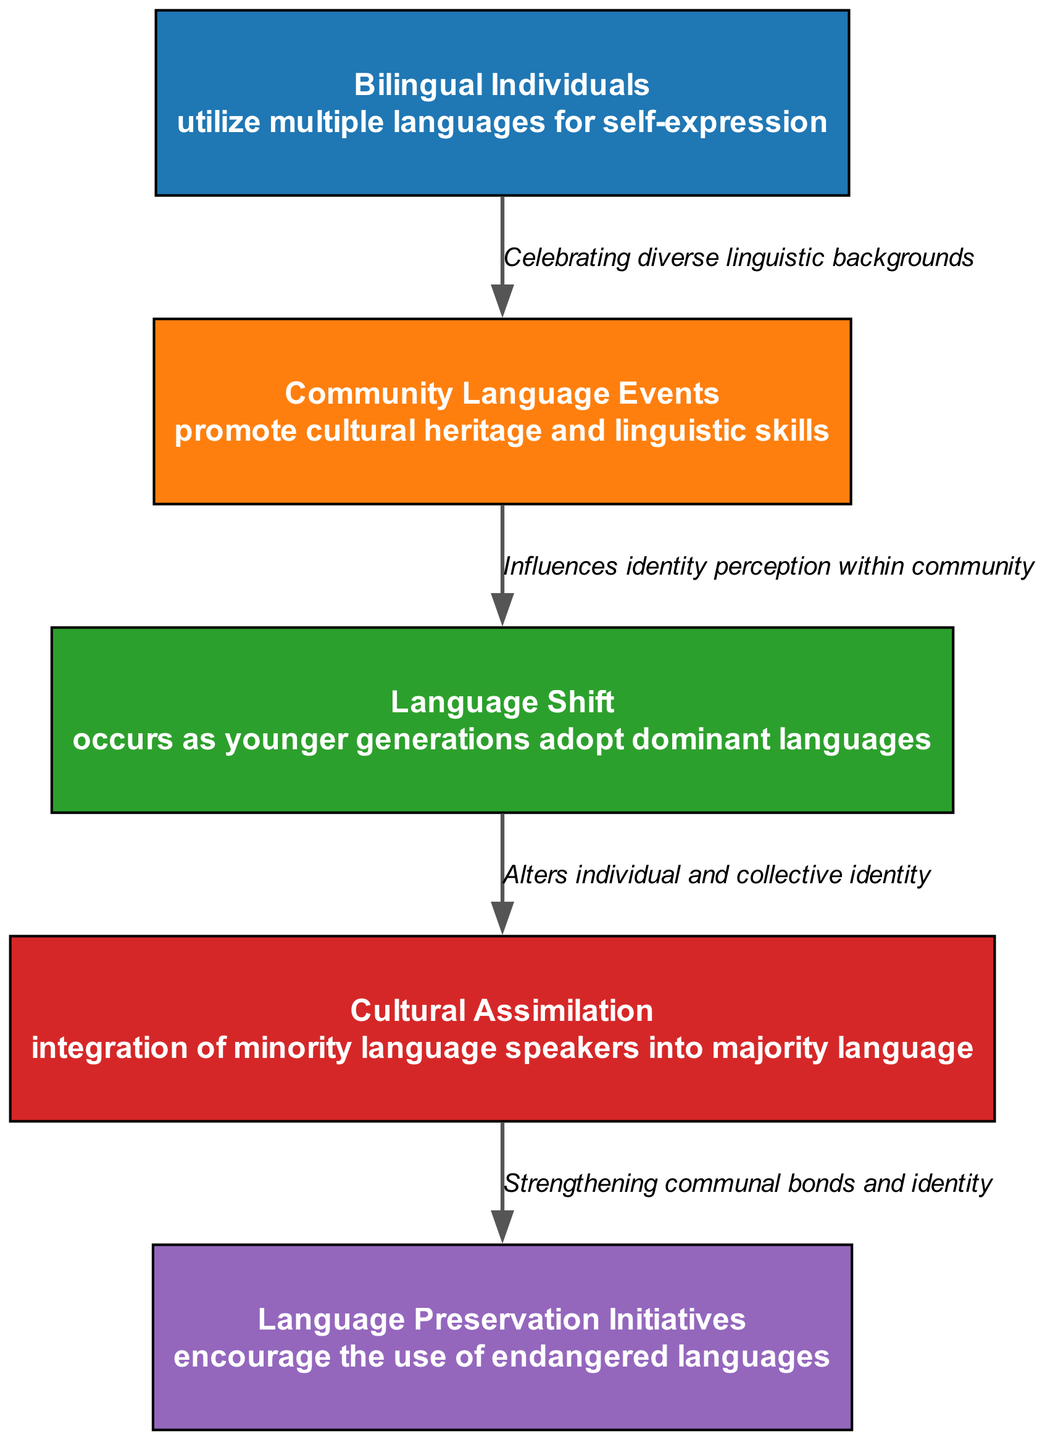What is the first element in the diagram? The diagram starts with the first node labeled "Bilingual Individuals."
Answer: Bilingual Individuals How many nodes are in the diagram? The diagram features five distinct nodes representing different aspects of language in multilingual communities.
Answer: 5 What action is associated with "Cultural Assimilation"? The "Cultural Assimilation" node indicates the action of integrating minority language speakers into the majority language.
Answer: Integration of minority language speakers into majority language Which element follows "Language Shift"? The "Cultural Assimilation" node follows the "Language Shift" node in the sequence, indicating a progression in language dynamics.
Answer: Cultural Assimilation What context is provided for "Community Language Events"? The context for "Community Language Events" is about celebrating diverse linguistic backgrounds.
Answer: Celebrating diverse linguistic backgrounds What connects "Language Preservation Initiatives" to the previous element? The edge connecting "Language Preservation Initiatives" indicates its role in strengthening communal bonds and identity.
Answer: Strengthening communal bonds and identity What is the relationship between "Bilingual Individuals" and "Language Shift"? "Bilingual Individuals" utilize multiple languages for self-expression, while "Language Shift" reflects the influence of dominant languages on younger generations’ identity, connected by the evolving dynamics of personal and community identity.
Answer: Evolving dynamics of personal and community identity Which element highlights the importance of endangered languages? The "Language Preservation Initiatives" element emphasizes the support and encouragement of using endangered languages.
Answer: Language Preservation Initiatives 